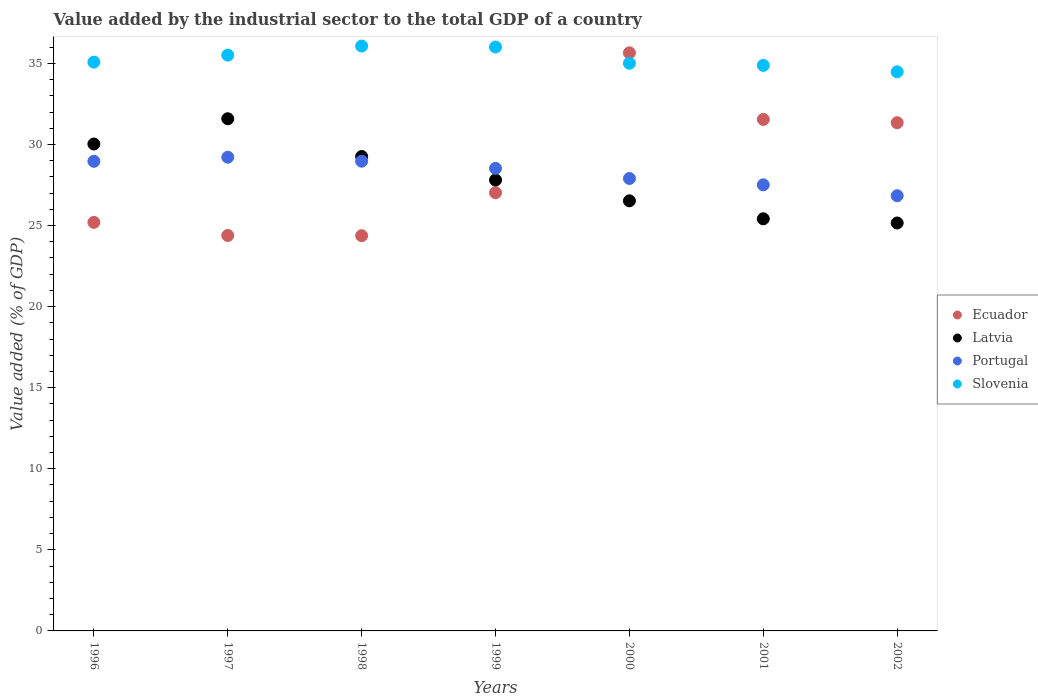How many different coloured dotlines are there?
Give a very brief answer. 4. Is the number of dotlines equal to the number of legend labels?
Give a very brief answer. Yes. What is the value added by the industrial sector to the total GDP in Slovenia in 1999?
Make the answer very short. 36.01. Across all years, what is the maximum value added by the industrial sector to the total GDP in Latvia?
Offer a very short reply. 31.59. Across all years, what is the minimum value added by the industrial sector to the total GDP in Ecuador?
Your answer should be compact. 24.37. In which year was the value added by the industrial sector to the total GDP in Ecuador minimum?
Ensure brevity in your answer.  1998. What is the total value added by the industrial sector to the total GDP in Slovenia in the graph?
Keep it short and to the point. 247.04. What is the difference between the value added by the industrial sector to the total GDP in Slovenia in 1997 and that in 1999?
Offer a terse response. -0.5. What is the difference between the value added by the industrial sector to the total GDP in Slovenia in 1999 and the value added by the industrial sector to the total GDP in Latvia in 1996?
Your answer should be compact. 5.98. What is the average value added by the industrial sector to the total GDP in Slovenia per year?
Ensure brevity in your answer.  35.29. In the year 1998, what is the difference between the value added by the industrial sector to the total GDP in Ecuador and value added by the industrial sector to the total GDP in Slovenia?
Offer a very short reply. -11.7. What is the ratio of the value added by the industrial sector to the total GDP in Latvia in 1999 to that in 2000?
Provide a short and direct response. 1.05. What is the difference between the highest and the second highest value added by the industrial sector to the total GDP in Slovenia?
Your response must be concise. 0.06. What is the difference between the highest and the lowest value added by the industrial sector to the total GDP in Portugal?
Your response must be concise. 2.38. Is the value added by the industrial sector to the total GDP in Latvia strictly greater than the value added by the industrial sector to the total GDP in Slovenia over the years?
Offer a terse response. No. How many years are there in the graph?
Keep it short and to the point. 7. Are the values on the major ticks of Y-axis written in scientific E-notation?
Make the answer very short. No. Does the graph contain grids?
Offer a terse response. No. Where does the legend appear in the graph?
Offer a very short reply. Center right. How are the legend labels stacked?
Provide a succinct answer. Vertical. What is the title of the graph?
Make the answer very short. Value added by the industrial sector to the total GDP of a country. Does "Hungary" appear as one of the legend labels in the graph?
Make the answer very short. No. What is the label or title of the Y-axis?
Provide a short and direct response. Value added (% of GDP). What is the Value added (% of GDP) in Ecuador in 1996?
Keep it short and to the point. 25.2. What is the Value added (% of GDP) in Latvia in 1996?
Your answer should be very brief. 30.03. What is the Value added (% of GDP) of Portugal in 1996?
Offer a terse response. 28.96. What is the Value added (% of GDP) in Slovenia in 1996?
Your response must be concise. 35.08. What is the Value added (% of GDP) of Ecuador in 1997?
Provide a succinct answer. 24.39. What is the Value added (% of GDP) in Latvia in 1997?
Provide a short and direct response. 31.59. What is the Value added (% of GDP) in Portugal in 1997?
Your response must be concise. 29.22. What is the Value added (% of GDP) of Slovenia in 1997?
Offer a very short reply. 35.51. What is the Value added (% of GDP) of Ecuador in 1998?
Ensure brevity in your answer.  24.37. What is the Value added (% of GDP) in Latvia in 1998?
Make the answer very short. 29.26. What is the Value added (% of GDP) in Portugal in 1998?
Your response must be concise. 28.97. What is the Value added (% of GDP) of Slovenia in 1998?
Provide a short and direct response. 36.07. What is the Value added (% of GDP) of Ecuador in 1999?
Provide a succinct answer. 27.02. What is the Value added (% of GDP) of Latvia in 1999?
Offer a terse response. 27.81. What is the Value added (% of GDP) in Portugal in 1999?
Make the answer very short. 28.53. What is the Value added (% of GDP) of Slovenia in 1999?
Your answer should be compact. 36.01. What is the Value added (% of GDP) of Ecuador in 2000?
Make the answer very short. 35.65. What is the Value added (% of GDP) in Latvia in 2000?
Give a very brief answer. 26.53. What is the Value added (% of GDP) in Portugal in 2000?
Your response must be concise. 27.9. What is the Value added (% of GDP) in Slovenia in 2000?
Offer a very short reply. 35.01. What is the Value added (% of GDP) in Ecuador in 2001?
Offer a terse response. 31.55. What is the Value added (% of GDP) in Latvia in 2001?
Make the answer very short. 25.42. What is the Value added (% of GDP) in Portugal in 2001?
Your response must be concise. 27.51. What is the Value added (% of GDP) in Slovenia in 2001?
Provide a succinct answer. 34.88. What is the Value added (% of GDP) of Ecuador in 2002?
Make the answer very short. 31.34. What is the Value added (% of GDP) of Latvia in 2002?
Give a very brief answer. 25.16. What is the Value added (% of GDP) in Portugal in 2002?
Provide a short and direct response. 26.84. What is the Value added (% of GDP) in Slovenia in 2002?
Your answer should be compact. 34.48. Across all years, what is the maximum Value added (% of GDP) in Ecuador?
Give a very brief answer. 35.65. Across all years, what is the maximum Value added (% of GDP) in Latvia?
Ensure brevity in your answer.  31.59. Across all years, what is the maximum Value added (% of GDP) in Portugal?
Provide a succinct answer. 29.22. Across all years, what is the maximum Value added (% of GDP) of Slovenia?
Provide a succinct answer. 36.07. Across all years, what is the minimum Value added (% of GDP) of Ecuador?
Your response must be concise. 24.37. Across all years, what is the minimum Value added (% of GDP) in Latvia?
Your response must be concise. 25.16. Across all years, what is the minimum Value added (% of GDP) of Portugal?
Your answer should be very brief. 26.84. Across all years, what is the minimum Value added (% of GDP) in Slovenia?
Provide a short and direct response. 34.48. What is the total Value added (% of GDP) of Ecuador in the graph?
Keep it short and to the point. 199.53. What is the total Value added (% of GDP) of Latvia in the graph?
Provide a succinct answer. 195.78. What is the total Value added (% of GDP) of Portugal in the graph?
Provide a short and direct response. 197.93. What is the total Value added (% of GDP) in Slovenia in the graph?
Make the answer very short. 247.04. What is the difference between the Value added (% of GDP) in Ecuador in 1996 and that in 1997?
Give a very brief answer. 0.81. What is the difference between the Value added (% of GDP) of Latvia in 1996 and that in 1997?
Give a very brief answer. -1.56. What is the difference between the Value added (% of GDP) in Portugal in 1996 and that in 1997?
Give a very brief answer. -0.25. What is the difference between the Value added (% of GDP) of Slovenia in 1996 and that in 1997?
Give a very brief answer. -0.43. What is the difference between the Value added (% of GDP) of Ecuador in 1996 and that in 1998?
Provide a succinct answer. 0.82. What is the difference between the Value added (% of GDP) of Latvia in 1996 and that in 1998?
Keep it short and to the point. 0.77. What is the difference between the Value added (% of GDP) of Portugal in 1996 and that in 1998?
Provide a succinct answer. -0.01. What is the difference between the Value added (% of GDP) in Slovenia in 1996 and that in 1998?
Offer a very short reply. -0.99. What is the difference between the Value added (% of GDP) in Ecuador in 1996 and that in 1999?
Provide a succinct answer. -1.83. What is the difference between the Value added (% of GDP) in Latvia in 1996 and that in 1999?
Provide a short and direct response. 2.22. What is the difference between the Value added (% of GDP) of Portugal in 1996 and that in 1999?
Ensure brevity in your answer.  0.43. What is the difference between the Value added (% of GDP) in Slovenia in 1996 and that in 1999?
Give a very brief answer. -0.93. What is the difference between the Value added (% of GDP) in Ecuador in 1996 and that in 2000?
Provide a short and direct response. -10.46. What is the difference between the Value added (% of GDP) in Latvia in 1996 and that in 2000?
Your response must be concise. 3.5. What is the difference between the Value added (% of GDP) in Portugal in 1996 and that in 2000?
Your answer should be very brief. 1.06. What is the difference between the Value added (% of GDP) of Slovenia in 1996 and that in 2000?
Keep it short and to the point. 0.07. What is the difference between the Value added (% of GDP) in Ecuador in 1996 and that in 2001?
Offer a terse response. -6.35. What is the difference between the Value added (% of GDP) of Latvia in 1996 and that in 2001?
Provide a short and direct response. 4.61. What is the difference between the Value added (% of GDP) in Portugal in 1996 and that in 2001?
Your answer should be compact. 1.45. What is the difference between the Value added (% of GDP) in Slovenia in 1996 and that in 2001?
Make the answer very short. 0.2. What is the difference between the Value added (% of GDP) of Ecuador in 1996 and that in 2002?
Ensure brevity in your answer.  -6.15. What is the difference between the Value added (% of GDP) of Latvia in 1996 and that in 2002?
Offer a very short reply. 4.87. What is the difference between the Value added (% of GDP) in Portugal in 1996 and that in 2002?
Offer a very short reply. 2.12. What is the difference between the Value added (% of GDP) of Slovenia in 1996 and that in 2002?
Give a very brief answer. 0.6. What is the difference between the Value added (% of GDP) in Ecuador in 1997 and that in 1998?
Keep it short and to the point. 0.01. What is the difference between the Value added (% of GDP) of Latvia in 1997 and that in 1998?
Your answer should be compact. 2.33. What is the difference between the Value added (% of GDP) of Portugal in 1997 and that in 1998?
Offer a very short reply. 0.25. What is the difference between the Value added (% of GDP) of Slovenia in 1997 and that in 1998?
Offer a terse response. -0.56. What is the difference between the Value added (% of GDP) in Ecuador in 1997 and that in 1999?
Ensure brevity in your answer.  -2.64. What is the difference between the Value added (% of GDP) in Latvia in 1997 and that in 1999?
Offer a terse response. 3.78. What is the difference between the Value added (% of GDP) in Portugal in 1997 and that in 1999?
Make the answer very short. 0.69. What is the difference between the Value added (% of GDP) in Slovenia in 1997 and that in 1999?
Provide a short and direct response. -0.5. What is the difference between the Value added (% of GDP) in Ecuador in 1997 and that in 2000?
Offer a terse response. -11.27. What is the difference between the Value added (% of GDP) in Latvia in 1997 and that in 2000?
Your answer should be very brief. 5.06. What is the difference between the Value added (% of GDP) in Portugal in 1997 and that in 2000?
Make the answer very short. 1.31. What is the difference between the Value added (% of GDP) in Slovenia in 1997 and that in 2000?
Your answer should be very brief. 0.5. What is the difference between the Value added (% of GDP) of Ecuador in 1997 and that in 2001?
Give a very brief answer. -7.16. What is the difference between the Value added (% of GDP) of Latvia in 1997 and that in 2001?
Ensure brevity in your answer.  6.17. What is the difference between the Value added (% of GDP) in Portugal in 1997 and that in 2001?
Ensure brevity in your answer.  1.7. What is the difference between the Value added (% of GDP) of Slovenia in 1997 and that in 2001?
Offer a very short reply. 0.63. What is the difference between the Value added (% of GDP) in Ecuador in 1997 and that in 2002?
Make the answer very short. -6.96. What is the difference between the Value added (% of GDP) of Latvia in 1997 and that in 2002?
Give a very brief answer. 6.43. What is the difference between the Value added (% of GDP) in Portugal in 1997 and that in 2002?
Your response must be concise. 2.38. What is the difference between the Value added (% of GDP) of Slovenia in 1997 and that in 2002?
Your answer should be compact. 1.03. What is the difference between the Value added (% of GDP) of Ecuador in 1998 and that in 1999?
Your response must be concise. -2.65. What is the difference between the Value added (% of GDP) of Latvia in 1998 and that in 1999?
Your answer should be compact. 1.45. What is the difference between the Value added (% of GDP) of Portugal in 1998 and that in 1999?
Offer a terse response. 0.44. What is the difference between the Value added (% of GDP) of Slovenia in 1998 and that in 1999?
Keep it short and to the point. 0.06. What is the difference between the Value added (% of GDP) in Ecuador in 1998 and that in 2000?
Provide a short and direct response. -11.28. What is the difference between the Value added (% of GDP) of Latvia in 1998 and that in 2000?
Provide a short and direct response. 2.73. What is the difference between the Value added (% of GDP) in Portugal in 1998 and that in 2000?
Offer a very short reply. 1.07. What is the difference between the Value added (% of GDP) of Slovenia in 1998 and that in 2000?
Provide a succinct answer. 1.06. What is the difference between the Value added (% of GDP) of Ecuador in 1998 and that in 2001?
Provide a succinct answer. -7.17. What is the difference between the Value added (% of GDP) of Latvia in 1998 and that in 2001?
Keep it short and to the point. 3.84. What is the difference between the Value added (% of GDP) in Portugal in 1998 and that in 2001?
Provide a short and direct response. 1.46. What is the difference between the Value added (% of GDP) of Slovenia in 1998 and that in 2001?
Your response must be concise. 1.19. What is the difference between the Value added (% of GDP) in Ecuador in 1998 and that in 2002?
Your answer should be very brief. -6.97. What is the difference between the Value added (% of GDP) in Latvia in 1998 and that in 2002?
Give a very brief answer. 4.1. What is the difference between the Value added (% of GDP) in Portugal in 1998 and that in 2002?
Ensure brevity in your answer.  2.13. What is the difference between the Value added (% of GDP) in Slovenia in 1998 and that in 2002?
Your response must be concise. 1.59. What is the difference between the Value added (% of GDP) in Ecuador in 1999 and that in 2000?
Make the answer very short. -8.63. What is the difference between the Value added (% of GDP) in Latvia in 1999 and that in 2000?
Keep it short and to the point. 1.28. What is the difference between the Value added (% of GDP) in Portugal in 1999 and that in 2000?
Ensure brevity in your answer.  0.62. What is the difference between the Value added (% of GDP) of Slovenia in 1999 and that in 2000?
Provide a short and direct response. 1. What is the difference between the Value added (% of GDP) in Ecuador in 1999 and that in 2001?
Make the answer very short. -4.52. What is the difference between the Value added (% of GDP) in Latvia in 1999 and that in 2001?
Offer a terse response. 2.39. What is the difference between the Value added (% of GDP) of Portugal in 1999 and that in 2001?
Provide a succinct answer. 1.02. What is the difference between the Value added (% of GDP) in Slovenia in 1999 and that in 2001?
Make the answer very short. 1.13. What is the difference between the Value added (% of GDP) of Ecuador in 1999 and that in 2002?
Keep it short and to the point. -4.32. What is the difference between the Value added (% of GDP) of Latvia in 1999 and that in 2002?
Keep it short and to the point. 2.65. What is the difference between the Value added (% of GDP) of Portugal in 1999 and that in 2002?
Provide a succinct answer. 1.69. What is the difference between the Value added (% of GDP) in Slovenia in 1999 and that in 2002?
Give a very brief answer. 1.53. What is the difference between the Value added (% of GDP) in Ecuador in 2000 and that in 2001?
Your response must be concise. 4.11. What is the difference between the Value added (% of GDP) in Latvia in 2000 and that in 2001?
Offer a terse response. 1.11. What is the difference between the Value added (% of GDP) of Portugal in 2000 and that in 2001?
Keep it short and to the point. 0.39. What is the difference between the Value added (% of GDP) in Slovenia in 2000 and that in 2001?
Give a very brief answer. 0.13. What is the difference between the Value added (% of GDP) of Ecuador in 2000 and that in 2002?
Keep it short and to the point. 4.31. What is the difference between the Value added (% of GDP) of Latvia in 2000 and that in 2002?
Your answer should be very brief. 1.37. What is the difference between the Value added (% of GDP) in Portugal in 2000 and that in 2002?
Your answer should be compact. 1.06. What is the difference between the Value added (% of GDP) of Slovenia in 2000 and that in 2002?
Provide a short and direct response. 0.53. What is the difference between the Value added (% of GDP) of Ecuador in 2001 and that in 2002?
Give a very brief answer. 0.2. What is the difference between the Value added (% of GDP) in Latvia in 2001 and that in 2002?
Provide a short and direct response. 0.26. What is the difference between the Value added (% of GDP) of Portugal in 2001 and that in 2002?
Provide a succinct answer. 0.67. What is the difference between the Value added (% of GDP) of Slovenia in 2001 and that in 2002?
Your answer should be compact. 0.4. What is the difference between the Value added (% of GDP) in Ecuador in 1996 and the Value added (% of GDP) in Latvia in 1997?
Your answer should be very brief. -6.39. What is the difference between the Value added (% of GDP) of Ecuador in 1996 and the Value added (% of GDP) of Portugal in 1997?
Give a very brief answer. -4.02. What is the difference between the Value added (% of GDP) in Ecuador in 1996 and the Value added (% of GDP) in Slovenia in 1997?
Provide a succinct answer. -10.31. What is the difference between the Value added (% of GDP) in Latvia in 1996 and the Value added (% of GDP) in Portugal in 1997?
Your response must be concise. 0.81. What is the difference between the Value added (% of GDP) of Latvia in 1996 and the Value added (% of GDP) of Slovenia in 1997?
Offer a terse response. -5.48. What is the difference between the Value added (% of GDP) of Portugal in 1996 and the Value added (% of GDP) of Slovenia in 1997?
Make the answer very short. -6.55. What is the difference between the Value added (% of GDP) of Ecuador in 1996 and the Value added (% of GDP) of Latvia in 1998?
Offer a terse response. -4.06. What is the difference between the Value added (% of GDP) of Ecuador in 1996 and the Value added (% of GDP) of Portugal in 1998?
Give a very brief answer. -3.77. What is the difference between the Value added (% of GDP) of Ecuador in 1996 and the Value added (% of GDP) of Slovenia in 1998?
Your answer should be compact. -10.87. What is the difference between the Value added (% of GDP) of Latvia in 1996 and the Value added (% of GDP) of Portugal in 1998?
Provide a succinct answer. 1.06. What is the difference between the Value added (% of GDP) of Latvia in 1996 and the Value added (% of GDP) of Slovenia in 1998?
Keep it short and to the point. -6.04. What is the difference between the Value added (% of GDP) of Portugal in 1996 and the Value added (% of GDP) of Slovenia in 1998?
Keep it short and to the point. -7.11. What is the difference between the Value added (% of GDP) of Ecuador in 1996 and the Value added (% of GDP) of Latvia in 1999?
Provide a short and direct response. -2.61. What is the difference between the Value added (% of GDP) of Ecuador in 1996 and the Value added (% of GDP) of Portugal in 1999?
Your answer should be very brief. -3.33. What is the difference between the Value added (% of GDP) in Ecuador in 1996 and the Value added (% of GDP) in Slovenia in 1999?
Ensure brevity in your answer.  -10.81. What is the difference between the Value added (% of GDP) in Latvia in 1996 and the Value added (% of GDP) in Portugal in 1999?
Give a very brief answer. 1.5. What is the difference between the Value added (% of GDP) in Latvia in 1996 and the Value added (% of GDP) in Slovenia in 1999?
Keep it short and to the point. -5.98. What is the difference between the Value added (% of GDP) in Portugal in 1996 and the Value added (% of GDP) in Slovenia in 1999?
Give a very brief answer. -7.05. What is the difference between the Value added (% of GDP) of Ecuador in 1996 and the Value added (% of GDP) of Latvia in 2000?
Ensure brevity in your answer.  -1.33. What is the difference between the Value added (% of GDP) of Ecuador in 1996 and the Value added (% of GDP) of Portugal in 2000?
Keep it short and to the point. -2.71. What is the difference between the Value added (% of GDP) in Ecuador in 1996 and the Value added (% of GDP) in Slovenia in 2000?
Give a very brief answer. -9.81. What is the difference between the Value added (% of GDP) of Latvia in 1996 and the Value added (% of GDP) of Portugal in 2000?
Give a very brief answer. 2.13. What is the difference between the Value added (% of GDP) in Latvia in 1996 and the Value added (% of GDP) in Slovenia in 2000?
Your answer should be very brief. -4.98. What is the difference between the Value added (% of GDP) in Portugal in 1996 and the Value added (% of GDP) in Slovenia in 2000?
Ensure brevity in your answer.  -6.05. What is the difference between the Value added (% of GDP) in Ecuador in 1996 and the Value added (% of GDP) in Latvia in 2001?
Make the answer very short. -0.22. What is the difference between the Value added (% of GDP) of Ecuador in 1996 and the Value added (% of GDP) of Portugal in 2001?
Offer a terse response. -2.31. What is the difference between the Value added (% of GDP) in Ecuador in 1996 and the Value added (% of GDP) in Slovenia in 2001?
Your answer should be compact. -9.68. What is the difference between the Value added (% of GDP) of Latvia in 1996 and the Value added (% of GDP) of Portugal in 2001?
Ensure brevity in your answer.  2.52. What is the difference between the Value added (% of GDP) of Latvia in 1996 and the Value added (% of GDP) of Slovenia in 2001?
Provide a succinct answer. -4.85. What is the difference between the Value added (% of GDP) in Portugal in 1996 and the Value added (% of GDP) in Slovenia in 2001?
Offer a terse response. -5.92. What is the difference between the Value added (% of GDP) of Ecuador in 1996 and the Value added (% of GDP) of Latvia in 2002?
Keep it short and to the point. 0.04. What is the difference between the Value added (% of GDP) of Ecuador in 1996 and the Value added (% of GDP) of Portugal in 2002?
Ensure brevity in your answer.  -1.64. What is the difference between the Value added (% of GDP) of Ecuador in 1996 and the Value added (% of GDP) of Slovenia in 2002?
Your answer should be compact. -9.28. What is the difference between the Value added (% of GDP) in Latvia in 1996 and the Value added (% of GDP) in Portugal in 2002?
Keep it short and to the point. 3.19. What is the difference between the Value added (% of GDP) of Latvia in 1996 and the Value added (% of GDP) of Slovenia in 2002?
Provide a short and direct response. -4.45. What is the difference between the Value added (% of GDP) in Portugal in 1996 and the Value added (% of GDP) in Slovenia in 2002?
Your response must be concise. -5.52. What is the difference between the Value added (% of GDP) in Ecuador in 1997 and the Value added (% of GDP) in Latvia in 1998?
Keep it short and to the point. -4.87. What is the difference between the Value added (% of GDP) of Ecuador in 1997 and the Value added (% of GDP) of Portugal in 1998?
Your answer should be very brief. -4.58. What is the difference between the Value added (% of GDP) of Ecuador in 1997 and the Value added (% of GDP) of Slovenia in 1998?
Offer a very short reply. -11.68. What is the difference between the Value added (% of GDP) in Latvia in 1997 and the Value added (% of GDP) in Portugal in 1998?
Give a very brief answer. 2.62. What is the difference between the Value added (% of GDP) in Latvia in 1997 and the Value added (% of GDP) in Slovenia in 1998?
Your answer should be very brief. -4.48. What is the difference between the Value added (% of GDP) in Portugal in 1997 and the Value added (% of GDP) in Slovenia in 1998?
Give a very brief answer. -6.85. What is the difference between the Value added (% of GDP) of Ecuador in 1997 and the Value added (% of GDP) of Latvia in 1999?
Make the answer very short. -3.42. What is the difference between the Value added (% of GDP) of Ecuador in 1997 and the Value added (% of GDP) of Portugal in 1999?
Give a very brief answer. -4.14. What is the difference between the Value added (% of GDP) in Ecuador in 1997 and the Value added (% of GDP) in Slovenia in 1999?
Provide a short and direct response. -11.62. What is the difference between the Value added (% of GDP) in Latvia in 1997 and the Value added (% of GDP) in Portugal in 1999?
Your answer should be compact. 3.06. What is the difference between the Value added (% of GDP) in Latvia in 1997 and the Value added (% of GDP) in Slovenia in 1999?
Make the answer very short. -4.42. What is the difference between the Value added (% of GDP) of Portugal in 1997 and the Value added (% of GDP) of Slovenia in 1999?
Provide a short and direct response. -6.79. What is the difference between the Value added (% of GDP) in Ecuador in 1997 and the Value added (% of GDP) in Latvia in 2000?
Provide a succinct answer. -2.14. What is the difference between the Value added (% of GDP) of Ecuador in 1997 and the Value added (% of GDP) of Portugal in 2000?
Provide a succinct answer. -3.52. What is the difference between the Value added (% of GDP) of Ecuador in 1997 and the Value added (% of GDP) of Slovenia in 2000?
Your response must be concise. -10.62. What is the difference between the Value added (% of GDP) of Latvia in 1997 and the Value added (% of GDP) of Portugal in 2000?
Your answer should be compact. 3.68. What is the difference between the Value added (% of GDP) of Latvia in 1997 and the Value added (% of GDP) of Slovenia in 2000?
Provide a short and direct response. -3.42. What is the difference between the Value added (% of GDP) in Portugal in 1997 and the Value added (% of GDP) in Slovenia in 2000?
Your response must be concise. -5.79. What is the difference between the Value added (% of GDP) in Ecuador in 1997 and the Value added (% of GDP) in Latvia in 2001?
Offer a very short reply. -1.03. What is the difference between the Value added (% of GDP) in Ecuador in 1997 and the Value added (% of GDP) in Portugal in 2001?
Provide a short and direct response. -3.12. What is the difference between the Value added (% of GDP) in Ecuador in 1997 and the Value added (% of GDP) in Slovenia in 2001?
Your answer should be compact. -10.49. What is the difference between the Value added (% of GDP) in Latvia in 1997 and the Value added (% of GDP) in Portugal in 2001?
Give a very brief answer. 4.07. What is the difference between the Value added (% of GDP) in Latvia in 1997 and the Value added (% of GDP) in Slovenia in 2001?
Keep it short and to the point. -3.29. What is the difference between the Value added (% of GDP) in Portugal in 1997 and the Value added (% of GDP) in Slovenia in 2001?
Provide a short and direct response. -5.66. What is the difference between the Value added (% of GDP) of Ecuador in 1997 and the Value added (% of GDP) of Latvia in 2002?
Offer a very short reply. -0.77. What is the difference between the Value added (% of GDP) of Ecuador in 1997 and the Value added (% of GDP) of Portugal in 2002?
Give a very brief answer. -2.45. What is the difference between the Value added (% of GDP) in Ecuador in 1997 and the Value added (% of GDP) in Slovenia in 2002?
Keep it short and to the point. -10.09. What is the difference between the Value added (% of GDP) of Latvia in 1997 and the Value added (% of GDP) of Portugal in 2002?
Provide a short and direct response. 4.75. What is the difference between the Value added (% of GDP) in Latvia in 1997 and the Value added (% of GDP) in Slovenia in 2002?
Keep it short and to the point. -2.89. What is the difference between the Value added (% of GDP) of Portugal in 1997 and the Value added (% of GDP) of Slovenia in 2002?
Give a very brief answer. -5.27. What is the difference between the Value added (% of GDP) of Ecuador in 1998 and the Value added (% of GDP) of Latvia in 1999?
Ensure brevity in your answer.  -3.43. What is the difference between the Value added (% of GDP) of Ecuador in 1998 and the Value added (% of GDP) of Portugal in 1999?
Offer a very short reply. -4.15. What is the difference between the Value added (% of GDP) in Ecuador in 1998 and the Value added (% of GDP) in Slovenia in 1999?
Provide a succinct answer. -11.64. What is the difference between the Value added (% of GDP) of Latvia in 1998 and the Value added (% of GDP) of Portugal in 1999?
Ensure brevity in your answer.  0.73. What is the difference between the Value added (% of GDP) of Latvia in 1998 and the Value added (% of GDP) of Slovenia in 1999?
Keep it short and to the point. -6.75. What is the difference between the Value added (% of GDP) of Portugal in 1998 and the Value added (% of GDP) of Slovenia in 1999?
Your answer should be compact. -7.04. What is the difference between the Value added (% of GDP) of Ecuador in 1998 and the Value added (% of GDP) of Latvia in 2000?
Your answer should be compact. -2.15. What is the difference between the Value added (% of GDP) of Ecuador in 1998 and the Value added (% of GDP) of Portugal in 2000?
Offer a very short reply. -3.53. What is the difference between the Value added (% of GDP) in Ecuador in 1998 and the Value added (% of GDP) in Slovenia in 2000?
Provide a succinct answer. -10.63. What is the difference between the Value added (% of GDP) of Latvia in 1998 and the Value added (% of GDP) of Portugal in 2000?
Provide a short and direct response. 1.36. What is the difference between the Value added (% of GDP) in Latvia in 1998 and the Value added (% of GDP) in Slovenia in 2000?
Give a very brief answer. -5.75. What is the difference between the Value added (% of GDP) in Portugal in 1998 and the Value added (% of GDP) in Slovenia in 2000?
Offer a very short reply. -6.04. What is the difference between the Value added (% of GDP) in Ecuador in 1998 and the Value added (% of GDP) in Latvia in 2001?
Offer a very short reply. -1.04. What is the difference between the Value added (% of GDP) of Ecuador in 1998 and the Value added (% of GDP) of Portugal in 2001?
Ensure brevity in your answer.  -3.14. What is the difference between the Value added (% of GDP) of Ecuador in 1998 and the Value added (% of GDP) of Slovenia in 2001?
Offer a very short reply. -10.5. What is the difference between the Value added (% of GDP) in Latvia in 1998 and the Value added (% of GDP) in Portugal in 2001?
Provide a succinct answer. 1.75. What is the difference between the Value added (% of GDP) in Latvia in 1998 and the Value added (% of GDP) in Slovenia in 2001?
Ensure brevity in your answer.  -5.62. What is the difference between the Value added (% of GDP) in Portugal in 1998 and the Value added (% of GDP) in Slovenia in 2001?
Make the answer very short. -5.91. What is the difference between the Value added (% of GDP) in Ecuador in 1998 and the Value added (% of GDP) in Latvia in 2002?
Your answer should be compact. -0.78. What is the difference between the Value added (% of GDP) of Ecuador in 1998 and the Value added (% of GDP) of Portugal in 2002?
Your response must be concise. -2.46. What is the difference between the Value added (% of GDP) of Ecuador in 1998 and the Value added (% of GDP) of Slovenia in 2002?
Ensure brevity in your answer.  -10.11. What is the difference between the Value added (% of GDP) in Latvia in 1998 and the Value added (% of GDP) in Portugal in 2002?
Provide a succinct answer. 2.42. What is the difference between the Value added (% of GDP) in Latvia in 1998 and the Value added (% of GDP) in Slovenia in 2002?
Ensure brevity in your answer.  -5.22. What is the difference between the Value added (% of GDP) of Portugal in 1998 and the Value added (% of GDP) of Slovenia in 2002?
Your answer should be compact. -5.51. What is the difference between the Value added (% of GDP) of Ecuador in 1999 and the Value added (% of GDP) of Latvia in 2000?
Ensure brevity in your answer.  0.5. What is the difference between the Value added (% of GDP) in Ecuador in 1999 and the Value added (% of GDP) in Portugal in 2000?
Your response must be concise. -0.88. What is the difference between the Value added (% of GDP) of Ecuador in 1999 and the Value added (% of GDP) of Slovenia in 2000?
Ensure brevity in your answer.  -7.98. What is the difference between the Value added (% of GDP) of Latvia in 1999 and the Value added (% of GDP) of Portugal in 2000?
Ensure brevity in your answer.  -0.1. What is the difference between the Value added (% of GDP) of Latvia in 1999 and the Value added (% of GDP) of Slovenia in 2000?
Offer a very short reply. -7.2. What is the difference between the Value added (% of GDP) of Portugal in 1999 and the Value added (% of GDP) of Slovenia in 2000?
Offer a terse response. -6.48. What is the difference between the Value added (% of GDP) of Ecuador in 1999 and the Value added (% of GDP) of Latvia in 2001?
Make the answer very short. 1.61. What is the difference between the Value added (% of GDP) of Ecuador in 1999 and the Value added (% of GDP) of Portugal in 2001?
Ensure brevity in your answer.  -0.49. What is the difference between the Value added (% of GDP) of Ecuador in 1999 and the Value added (% of GDP) of Slovenia in 2001?
Offer a terse response. -7.85. What is the difference between the Value added (% of GDP) of Latvia in 1999 and the Value added (% of GDP) of Portugal in 2001?
Ensure brevity in your answer.  0.3. What is the difference between the Value added (% of GDP) of Latvia in 1999 and the Value added (% of GDP) of Slovenia in 2001?
Provide a short and direct response. -7.07. What is the difference between the Value added (% of GDP) of Portugal in 1999 and the Value added (% of GDP) of Slovenia in 2001?
Your response must be concise. -6.35. What is the difference between the Value added (% of GDP) of Ecuador in 1999 and the Value added (% of GDP) of Latvia in 2002?
Give a very brief answer. 1.87. What is the difference between the Value added (% of GDP) in Ecuador in 1999 and the Value added (% of GDP) in Portugal in 2002?
Make the answer very short. 0.19. What is the difference between the Value added (% of GDP) in Ecuador in 1999 and the Value added (% of GDP) in Slovenia in 2002?
Offer a terse response. -7.46. What is the difference between the Value added (% of GDP) of Latvia in 1999 and the Value added (% of GDP) of Portugal in 2002?
Your answer should be very brief. 0.97. What is the difference between the Value added (% of GDP) of Latvia in 1999 and the Value added (% of GDP) of Slovenia in 2002?
Offer a very short reply. -6.67. What is the difference between the Value added (% of GDP) of Portugal in 1999 and the Value added (% of GDP) of Slovenia in 2002?
Give a very brief answer. -5.95. What is the difference between the Value added (% of GDP) in Ecuador in 2000 and the Value added (% of GDP) in Latvia in 2001?
Your response must be concise. 10.24. What is the difference between the Value added (% of GDP) of Ecuador in 2000 and the Value added (% of GDP) of Portugal in 2001?
Offer a terse response. 8.14. What is the difference between the Value added (% of GDP) in Ecuador in 2000 and the Value added (% of GDP) in Slovenia in 2001?
Your answer should be very brief. 0.77. What is the difference between the Value added (% of GDP) of Latvia in 2000 and the Value added (% of GDP) of Portugal in 2001?
Your answer should be compact. -0.99. What is the difference between the Value added (% of GDP) in Latvia in 2000 and the Value added (% of GDP) in Slovenia in 2001?
Your answer should be compact. -8.35. What is the difference between the Value added (% of GDP) of Portugal in 2000 and the Value added (% of GDP) of Slovenia in 2001?
Make the answer very short. -6.98. What is the difference between the Value added (% of GDP) in Ecuador in 2000 and the Value added (% of GDP) in Latvia in 2002?
Your answer should be very brief. 10.5. What is the difference between the Value added (% of GDP) of Ecuador in 2000 and the Value added (% of GDP) of Portugal in 2002?
Provide a short and direct response. 8.81. What is the difference between the Value added (% of GDP) of Ecuador in 2000 and the Value added (% of GDP) of Slovenia in 2002?
Ensure brevity in your answer.  1.17. What is the difference between the Value added (% of GDP) of Latvia in 2000 and the Value added (% of GDP) of Portugal in 2002?
Give a very brief answer. -0.31. What is the difference between the Value added (% of GDP) in Latvia in 2000 and the Value added (% of GDP) in Slovenia in 2002?
Provide a short and direct response. -7.95. What is the difference between the Value added (% of GDP) of Portugal in 2000 and the Value added (% of GDP) of Slovenia in 2002?
Your answer should be compact. -6.58. What is the difference between the Value added (% of GDP) in Ecuador in 2001 and the Value added (% of GDP) in Latvia in 2002?
Your answer should be very brief. 6.39. What is the difference between the Value added (% of GDP) of Ecuador in 2001 and the Value added (% of GDP) of Portugal in 2002?
Offer a terse response. 4.71. What is the difference between the Value added (% of GDP) in Ecuador in 2001 and the Value added (% of GDP) in Slovenia in 2002?
Your answer should be compact. -2.93. What is the difference between the Value added (% of GDP) of Latvia in 2001 and the Value added (% of GDP) of Portugal in 2002?
Your answer should be very brief. -1.42. What is the difference between the Value added (% of GDP) in Latvia in 2001 and the Value added (% of GDP) in Slovenia in 2002?
Your response must be concise. -9.06. What is the difference between the Value added (% of GDP) of Portugal in 2001 and the Value added (% of GDP) of Slovenia in 2002?
Keep it short and to the point. -6.97. What is the average Value added (% of GDP) of Ecuador per year?
Ensure brevity in your answer.  28.5. What is the average Value added (% of GDP) of Latvia per year?
Keep it short and to the point. 27.97. What is the average Value added (% of GDP) of Portugal per year?
Provide a short and direct response. 28.28. What is the average Value added (% of GDP) in Slovenia per year?
Provide a short and direct response. 35.29. In the year 1996, what is the difference between the Value added (% of GDP) of Ecuador and Value added (% of GDP) of Latvia?
Offer a very short reply. -4.83. In the year 1996, what is the difference between the Value added (% of GDP) in Ecuador and Value added (% of GDP) in Portugal?
Give a very brief answer. -3.77. In the year 1996, what is the difference between the Value added (% of GDP) of Ecuador and Value added (% of GDP) of Slovenia?
Your answer should be compact. -9.88. In the year 1996, what is the difference between the Value added (% of GDP) in Latvia and Value added (% of GDP) in Portugal?
Provide a succinct answer. 1.07. In the year 1996, what is the difference between the Value added (% of GDP) in Latvia and Value added (% of GDP) in Slovenia?
Keep it short and to the point. -5.05. In the year 1996, what is the difference between the Value added (% of GDP) in Portugal and Value added (% of GDP) in Slovenia?
Make the answer very short. -6.12. In the year 1997, what is the difference between the Value added (% of GDP) of Ecuador and Value added (% of GDP) of Latvia?
Keep it short and to the point. -7.2. In the year 1997, what is the difference between the Value added (% of GDP) of Ecuador and Value added (% of GDP) of Portugal?
Provide a short and direct response. -4.83. In the year 1997, what is the difference between the Value added (% of GDP) of Ecuador and Value added (% of GDP) of Slovenia?
Keep it short and to the point. -11.12. In the year 1997, what is the difference between the Value added (% of GDP) of Latvia and Value added (% of GDP) of Portugal?
Give a very brief answer. 2.37. In the year 1997, what is the difference between the Value added (% of GDP) in Latvia and Value added (% of GDP) in Slovenia?
Your answer should be compact. -3.92. In the year 1997, what is the difference between the Value added (% of GDP) in Portugal and Value added (% of GDP) in Slovenia?
Your answer should be compact. -6.3. In the year 1998, what is the difference between the Value added (% of GDP) in Ecuador and Value added (% of GDP) in Latvia?
Your answer should be very brief. -4.88. In the year 1998, what is the difference between the Value added (% of GDP) in Ecuador and Value added (% of GDP) in Portugal?
Provide a short and direct response. -4.59. In the year 1998, what is the difference between the Value added (% of GDP) in Ecuador and Value added (% of GDP) in Slovenia?
Offer a very short reply. -11.7. In the year 1998, what is the difference between the Value added (% of GDP) in Latvia and Value added (% of GDP) in Portugal?
Make the answer very short. 0.29. In the year 1998, what is the difference between the Value added (% of GDP) of Latvia and Value added (% of GDP) of Slovenia?
Make the answer very short. -6.81. In the year 1998, what is the difference between the Value added (% of GDP) of Portugal and Value added (% of GDP) of Slovenia?
Your response must be concise. -7.1. In the year 1999, what is the difference between the Value added (% of GDP) of Ecuador and Value added (% of GDP) of Latvia?
Your answer should be very brief. -0.78. In the year 1999, what is the difference between the Value added (% of GDP) of Ecuador and Value added (% of GDP) of Portugal?
Make the answer very short. -1.5. In the year 1999, what is the difference between the Value added (% of GDP) of Ecuador and Value added (% of GDP) of Slovenia?
Keep it short and to the point. -8.99. In the year 1999, what is the difference between the Value added (% of GDP) of Latvia and Value added (% of GDP) of Portugal?
Ensure brevity in your answer.  -0.72. In the year 1999, what is the difference between the Value added (% of GDP) in Latvia and Value added (% of GDP) in Slovenia?
Provide a succinct answer. -8.2. In the year 1999, what is the difference between the Value added (% of GDP) in Portugal and Value added (% of GDP) in Slovenia?
Ensure brevity in your answer.  -7.48. In the year 2000, what is the difference between the Value added (% of GDP) in Ecuador and Value added (% of GDP) in Latvia?
Offer a very short reply. 9.13. In the year 2000, what is the difference between the Value added (% of GDP) in Ecuador and Value added (% of GDP) in Portugal?
Ensure brevity in your answer.  7.75. In the year 2000, what is the difference between the Value added (% of GDP) in Ecuador and Value added (% of GDP) in Slovenia?
Provide a succinct answer. 0.65. In the year 2000, what is the difference between the Value added (% of GDP) of Latvia and Value added (% of GDP) of Portugal?
Provide a succinct answer. -1.38. In the year 2000, what is the difference between the Value added (% of GDP) of Latvia and Value added (% of GDP) of Slovenia?
Give a very brief answer. -8.48. In the year 2000, what is the difference between the Value added (% of GDP) of Portugal and Value added (% of GDP) of Slovenia?
Offer a terse response. -7.11. In the year 2001, what is the difference between the Value added (% of GDP) of Ecuador and Value added (% of GDP) of Latvia?
Your answer should be compact. 6.13. In the year 2001, what is the difference between the Value added (% of GDP) in Ecuador and Value added (% of GDP) in Portugal?
Make the answer very short. 4.03. In the year 2001, what is the difference between the Value added (% of GDP) of Ecuador and Value added (% of GDP) of Slovenia?
Keep it short and to the point. -3.33. In the year 2001, what is the difference between the Value added (% of GDP) in Latvia and Value added (% of GDP) in Portugal?
Offer a very short reply. -2.1. In the year 2001, what is the difference between the Value added (% of GDP) of Latvia and Value added (% of GDP) of Slovenia?
Ensure brevity in your answer.  -9.46. In the year 2001, what is the difference between the Value added (% of GDP) in Portugal and Value added (% of GDP) in Slovenia?
Your answer should be compact. -7.37. In the year 2002, what is the difference between the Value added (% of GDP) in Ecuador and Value added (% of GDP) in Latvia?
Give a very brief answer. 6.19. In the year 2002, what is the difference between the Value added (% of GDP) in Ecuador and Value added (% of GDP) in Portugal?
Keep it short and to the point. 4.5. In the year 2002, what is the difference between the Value added (% of GDP) in Ecuador and Value added (% of GDP) in Slovenia?
Provide a succinct answer. -3.14. In the year 2002, what is the difference between the Value added (% of GDP) of Latvia and Value added (% of GDP) of Portugal?
Your answer should be very brief. -1.68. In the year 2002, what is the difference between the Value added (% of GDP) of Latvia and Value added (% of GDP) of Slovenia?
Keep it short and to the point. -9.32. In the year 2002, what is the difference between the Value added (% of GDP) of Portugal and Value added (% of GDP) of Slovenia?
Give a very brief answer. -7.64. What is the ratio of the Value added (% of GDP) of Ecuador in 1996 to that in 1997?
Your answer should be compact. 1.03. What is the ratio of the Value added (% of GDP) in Latvia in 1996 to that in 1997?
Make the answer very short. 0.95. What is the ratio of the Value added (% of GDP) in Ecuador in 1996 to that in 1998?
Provide a succinct answer. 1.03. What is the ratio of the Value added (% of GDP) in Latvia in 1996 to that in 1998?
Make the answer very short. 1.03. What is the ratio of the Value added (% of GDP) in Slovenia in 1996 to that in 1998?
Your answer should be very brief. 0.97. What is the ratio of the Value added (% of GDP) in Ecuador in 1996 to that in 1999?
Provide a short and direct response. 0.93. What is the ratio of the Value added (% of GDP) in Latvia in 1996 to that in 1999?
Offer a terse response. 1.08. What is the ratio of the Value added (% of GDP) in Portugal in 1996 to that in 1999?
Provide a short and direct response. 1.02. What is the ratio of the Value added (% of GDP) of Slovenia in 1996 to that in 1999?
Ensure brevity in your answer.  0.97. What is the ratio of the Value added (% of GDP) in Ecuador in 1996 to that in 2000?
Keep it short and to the point. 0.71. What is the ratio of the Value added (% of GDP) in Latvia in 1996 to that in 2000?
Offer a terse response. 1.13. What is the ratio of the Value added (% of GDP) in Portugal in 1996 to that in 2000?
Your answer should be very brief. 1.04. What is the ratio of the Value added (% of GDP) in Ecuador in 1996 to that in 2001?
Make the answer very short. 0.8. What is the ratio of the Value added (% of GDP) of Latvia in 1996 to that in 2001?
Your answer should be very brief. 1.18. What is the ratio of the Value added (% of GDP) of Portugal in 1996 to that in 2001?
Your response must be concise. 1.05. What is the ratio of the Value added (% of GDP) in Slovenia in 1996 to that in 2001?
Your answer should be very brief. 1.01. What is the ratio of the Value added (% of GDP) of Ecuador in 1996 to that in 2002?
Give a very brief answer. 0.8. What is the ratio of the Value added (% of GDP) of Latvia in 1996 to that in 2002?
Your answer should be compact. 1.19. What is the ratio of the Value added (% of GDP) in Portugal in 1996 to that in 2002?
Give a very brief answer. 1.08. What is the ratio of the Value added (% of GDP) of Slovenia in 1996 to that in 2002?
Give a very brief answer. 1.02. What is the ratio of the Value added (% of GDP) of Ecuador in 1997 to that in 1998?
Offer a terse response. 1. What is the ratio of the Value added (% of GDP) in Latvia in 1997 to that in 1998?
Keep it short and to the point. 1.08. What is the ratio of the Value added (% of GDP) in Portugal in 1997 to that in 1998?
Your response must be concise. 1.01. What is the ratio of the Value added (% of GDP) of Slovenia in 1997 to that in 1998?
Provide a short and direct response. 0.98. What is the ratio of the Value added (% of GDP) in Ecuador in 1997 to that in 1999?
Give a very brief answer. 0.9. What is the ratio of the Value added (% of GDP) of Latvia in 1997 to that in 1999?
Your response must be concise. 1.14. What is the ratio of the Value added (% of GDP) in Portugal in 1997 to that in 1999?
Make the answer very short. 1.02. What is the ratio of the Value added (% of GDP) of Slovenia in 1997 to that in 1999?
Your answer should be compact. 0.99. What is the ratio of the Value added (% of GDP) in Ecuador in 1997 to that in 2000?
Provide a succinct answer. 0.68. What is the ratio of the Value added (% of GDP) of Latvia in 1997 to that in 2000?
Your response must be concise. 1.19. What is the ratio of the Value added (% of GDP) of Portugal in 1997 to that in 2000?
Offer a terse response. 1.05. What is the ratio of the Value added (% of GDP) in Slovenia in 1997 to that in 2000?
Your answer should be compact. 1.01. What is the ratio of the Value added (% of GDP) in Ecuador in 1997 to that in 2001?
Offer a very short reply. 0.77. What is the ratio of the Value added (% of GDP) in Latvia in 1997 to that in 2001?
Ensure brevity in your answer.  1.24. What is the ratio of the Value added (% of GDP) of Portugal in 1997 to that in 2001?
Make the answer very short. 1.06. What is the ratio of the Value added (% of GDP) in Slovenia in 1997 to that in 2001?
Your answer should be very brief. 1.02. What is the ratio of the Value added (% of GDP) in Ecuador in 1997 to that in 2002?
Offer a very short reply. 0.78. What is the ratio of the Value added (% of GDP) in Latvia in 1997 to that in 2002?
Keep it short and to the point. 1.26. What is the ratio of the Value added (% of GDP) in Portugal in 1997 to that in 2002?
Ensure brevity in your answer.  1.09. What is the ratio of the Value added (% of GDP) of Slovenia in 1997 to that in 2002?
Your answer should be compact. 1.03. What is the ratio of the Value added (% of GDP) of Ecuador in 1998 to that in 1999?
Give a very brief answer. 0.9. What is the ratio of the Value added (% of GDP) of Latvia in 1998 to that in 1999?
Offer a terse response. 1.05. What is the ratio of the Value added (% of GDP) in Portugal in 1998 to that in 1999?
Make the answer very short. 1.02. What is the ratio of the Value added (% of GDP) in Ecuador in 1998 to that in 2000?
Make the answer very short. 0.68. What is the ratio of the Value added (% of GDP) in Latvia in 1998 to that in 2000?
Your answer should be compact. 1.1. What is the ratio of the Value added (% of GDP) in Portugal in 1998 to that in 2000?
Ensure brevity in your answer.  1.04. What is the ratio of the Value added (% of GDP) in Slovenia in 1998 to that in 2000?
Your answer should be compact. 1.03. What is the ratio of the Value added (% of GDP) of Ecuador in 1998 to that in 2001?
Your answer should be very brief. 0.77. What is the ratio of the Value added (% of GDP) in Latvia in 1998 to that in 2001?
Your answer should be compact. 1.15. What is the ratio of the Value added (% of GDP) in Portugal in 1998 to that in 2001?
Give a very brief answer. 1.05. What is the ratio of the Value added (% of GDP) in Slovenia in 1998 to that in 2001?
Ensure brevity in your answer.  1.03. What is the ratio of the Value added (% of GDP) in Ecuador in 1998 to that in 2002?
Keep it short and to the point. 0.78. What is the ratio of the Value added (% of GDP) in Latvia in 1998 to that in 2002?
Offer a very short reply. 1.16. What is the ratio of the Value added (% of GDP) of Portugal in 1998 to that in 2002?
Give a very brief answer. 1.08. What is the ratio of the Value added (% of GDP) in Slovenia in 1998 to that in 2002?
Offer a terse response. 1.05. What is the ratio of the Value added (% of GDP) of Ecuador in 1999 to that in 2000?
Make the answer very short. 0.76. What is the ratio of the Value added (% of GDP) of Latvia in 1999 to that in 2000?
Your answer should be compact. 1.05. What is the ratio of the Value added (% of GDP) in Portugal in 1999 to that in 2000?
Provide a short and direct response. 1.02. What is the ratio of the Value added (% of GDP) in Slovenia in 1999 to that in 2000?
Offer a terse response. 1.03. What is the ratio of the Value added (% of GDP) in Ecuador in 1999 to that in 2001?
Offer a terse response. 0.86. What is the ratio of the Value added (% of GDP) in Latvia in 1999 to that in 2001?
Keep it short and to the point. 1.09. What is the ratio of the Value added (% of GDP) of Portugal in 1999 to that in 2001?
Ensure brevity in your answer.  1.04. What is the ratio of the Value added (% of GDP) of Slovenia in 1999 to that in 2001?
Your response must be concise. 1.03. What is the ratio of the Value added (% of GDP) of Ecuador in 1999 to that in 2002?
Offer a very short reply. 0.86. What is the ratio of the Value added (% of GDP) in Latvia in 1999 to that in 2002?
Your response must be concise. 1.11. What is the ratio of the Value added (% of GDP) in Portugal in 1999 to that in 2002?
Your answer should be compact. 1.06. What is the ratio of the Value added (% of GDP) of Slovenia in 1999 to that in 2002?
Provide a short and direct response. 1.04. What is the ratio of the Value added (% of GDP) of Ecuador in 2000 to that in 2001?
Offer a terse response. 1.13. What is the ratio of the Value added (% of GDP) in Latvia in 2000 to that in 2001?
Offer a terse response. 1.04. What is the ratio of the Value added (% of GDP) of Portugal in 2000 to that in 2001?
Your answer should be compact. 1.01. What is the ratio of the Value added (% of GDP) of Ecuador in 2000 to that in 2002?
Your response must be concise. 1.14. What is the ratio of the Value added (% of GDP) of Latvia in 2000 to that in 2002?
Your response must be concise. 1.05. What is the ratio of the Value added (% of GDP) in Portugal in 2000 to that in 2002?
Provide a succinct answer. 1.04. What is the ratio of the Value added (% of GDP) of Slovenia in 2000 to that in 2002?
Your answer should be compact. 1.02. What is the ratio of the Value added (% of GDP) of Ecuador in 2001 to that in 2002?
Make the answer very short. 1.01. What is the ratio of the Value added (% of GDP) of Latvia in 2001 to that in 2002?
Your response must be concise. 1.01. What is the ratio of the Value added (% of GDP) of Portugal in 2001 to that in 2002?
Provide a succinct answer. 1.03. What is the ratio of the Value added (% of GDP) of Slovenia in 2001 to that in 2002?
Provide a succinct answer. 1.01. What is the difference between the highest and the second highest Value added (% of GDP) in Ecuador?
Keep it short and to the point. 4.11. What is the difference between the highest and the second highest Value added (% of GDP) of Latvia?
Your response must be concise. 1.56. What is the difference between the highest and the second highest Value added (% of GDP) in Portugal?
Keep it short and to the point. 0.25. What is the difference between the highest and the second highest Value added (% of GDP) in Slovenia?
Make the answer very short. 0.06. What is the difference between the highest and the lowest Value added (% of GDP) in Ecuador?
Keep it short and to the point. 11.28. What is the difference between the highest and the lowest Value added (% of GDP) of Latvia?
Your answer should be compact. 6.43. What is the difference between the highest and the lowest Value added (% of GDP) in Portugal?
Provide a succinct answer. 2.38. What is the difference between the highest and the lowest Value added (% of GDP) of Slovenia?
Keep it short and to the point. 1.59. 